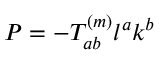Convert formula to latex. <formula><loc_0><loc_0><loc_500><loc_500>P = - T _ { a b } ^ { ( m ) } l ^ { a } k ^ { b }</formula> 